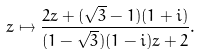<formula> <loc_0><loc_0><loc_500><loc_500>z \mapsto \frac { 2 z + ( \sqrt { 3 } - 1 ) ( 1 + i ) } { ( 1 - \sqrt { 3 } ) ( 1 - i ) z + 2 } .</formula> 